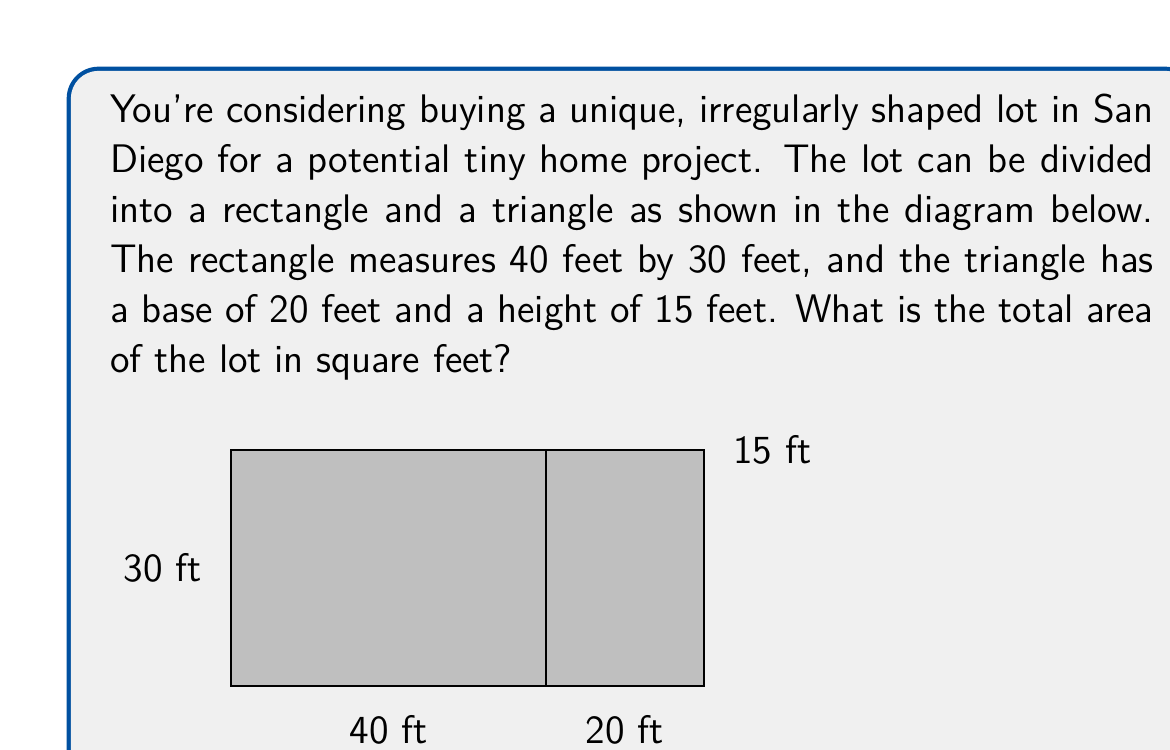Provide a solution to this math problem. To find the total area of the irregularly shaped lot, we need to calculate the areas of the rectangle and triangle separately, then add them together.

1. Area of the rectangle:
   $$ A_\text{rectangle} = \text{length} \times \text{width} $$
   $$ A_\text{rectangle} = 40 \text{ ft} \times 30 \text{ ft} = 1200 \text{ sq ft} $$

2. Area of the triangle:
   $$ A_\text{triangle} = \frac{1}{2} \times \text{base} \times \text{height} $$
   $$ A_\text{triangle} = \frac{1}{2} \times 20 \text{ ft} \times 15 \text{ ft} = 150 \text{ sq ft} $$

3. Total area of the lot:
   $$ A_\text{total} = A_\text{rectangle} + A_\text{triangle} $$
   $$ A_\text{total} = 1200 \text{ sq ft} + 150 \text{ sq ft} = 1350 \text{ sq ft} $$

Therefore, the total area of the irregularly shaped lot is 1350 square feet.
Answer: 1350 sq ft 